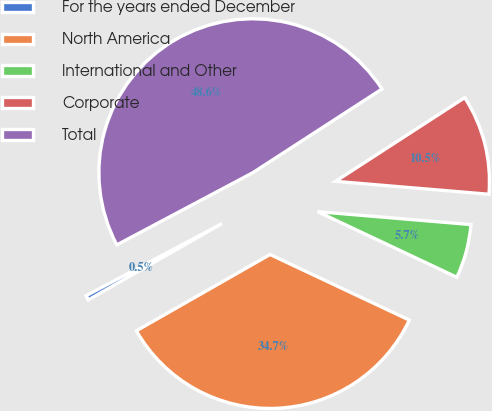Convert chart. <chart><loc_0><loc_0><loc_500><loc_500><pie_chart><fcel>For the years ended December<fcel>North America<fcel>International and Other<fcel>Corporate<fcel>Total<nl><fcel>0.49%<fcel>34.74%<fcel>5.67%<fcel>10.49%<fcel>48.62%<nl></chart> 